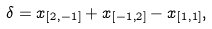Convert formula to latex. <formula><loc_0><loc_0><loc_500><loc_500>\delta = x _ { [ 2 , - 1 ] } + x _ { [ - 1 , 2 ] } - x _ { [ 1 , 1 ] } ,</formula> 